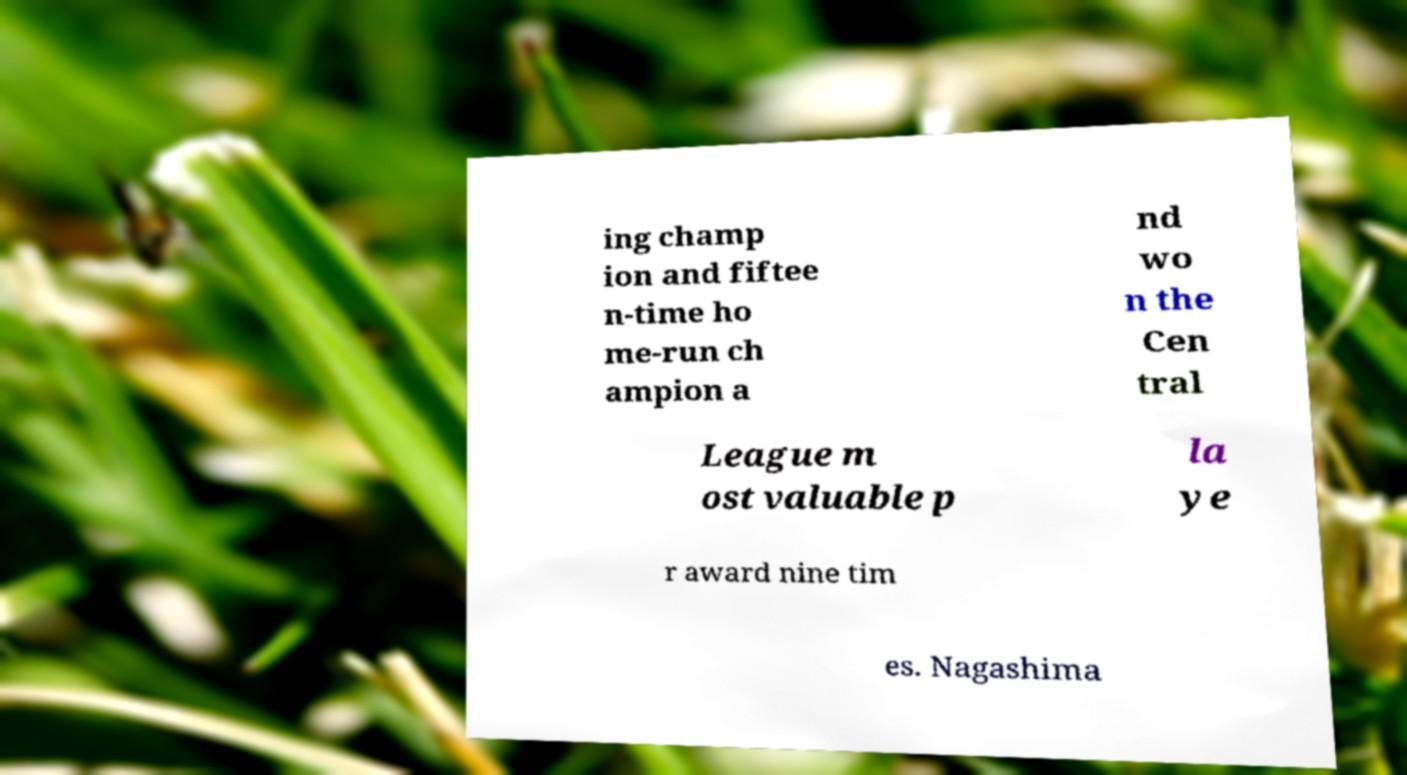Please identify and transcribe the text found in this image. ing champ ion and fiftee n-time ho me-run ch ampion a nd wo n the Cen tral League m ost valuable p la ye r award nine tim es. Nagashima 